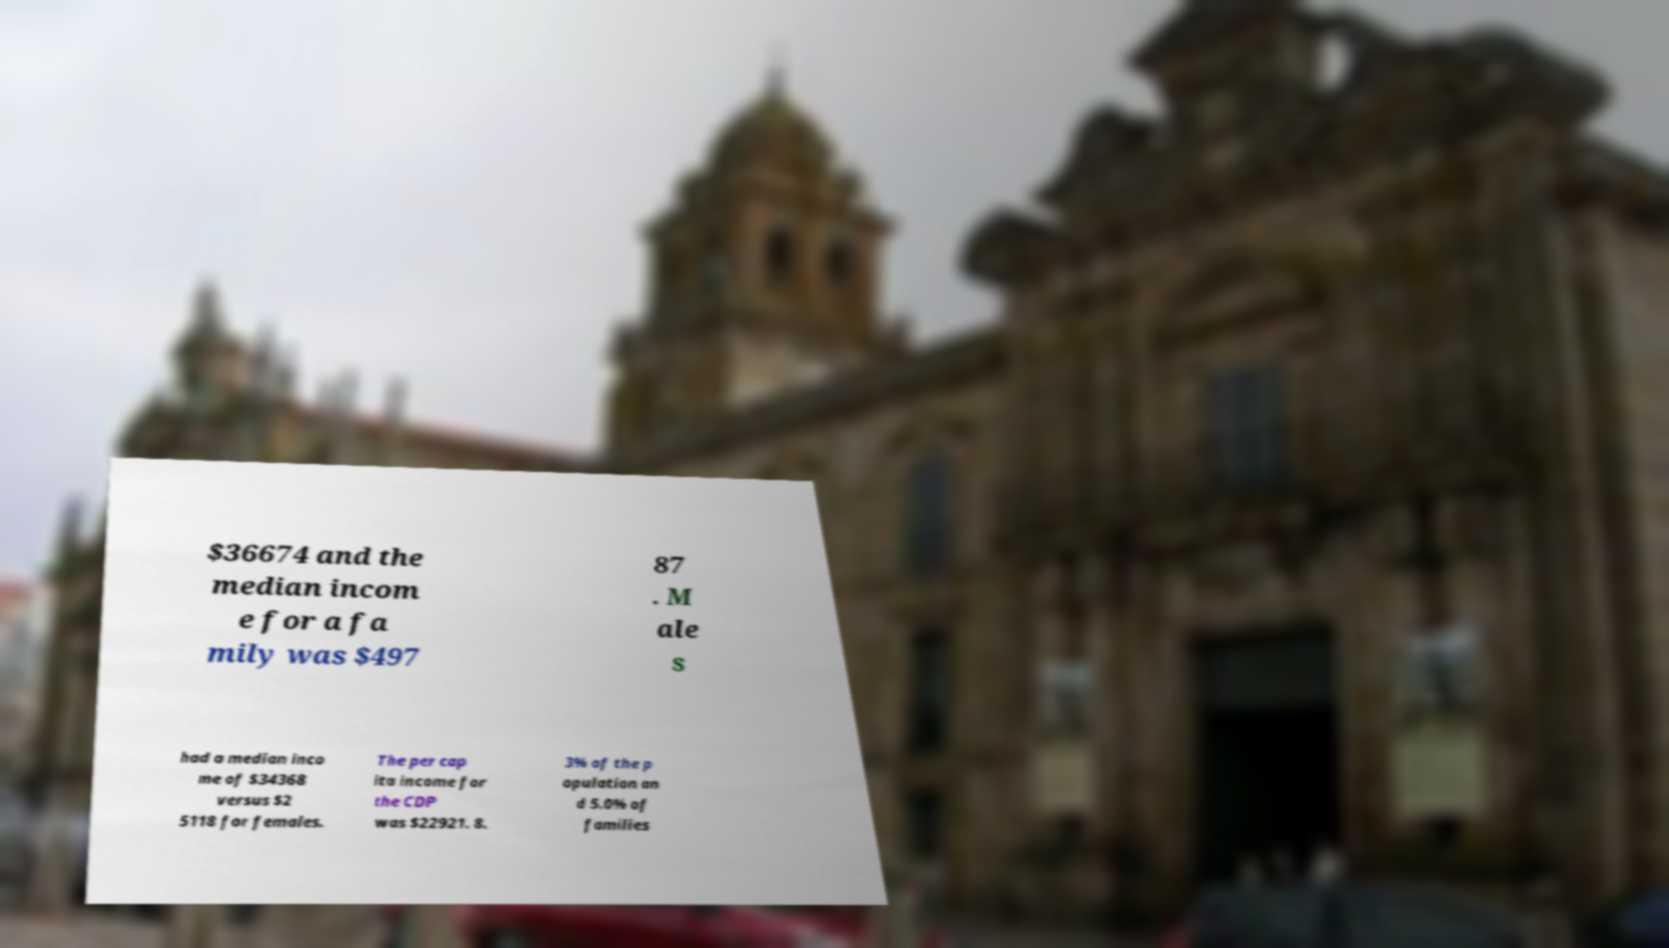Can you read and provide the text displayed in the image?This photo seems to have some interesting text. Can you extract and type it out for me? $36674 and the median incom e for a fa mily was $497 87 . M ale s had a median inco me of $34368 versus $2 5118 for females. The per cap ita income for the CDP was $22921. 8. 3% of the p opulation an d 5.0% of families 